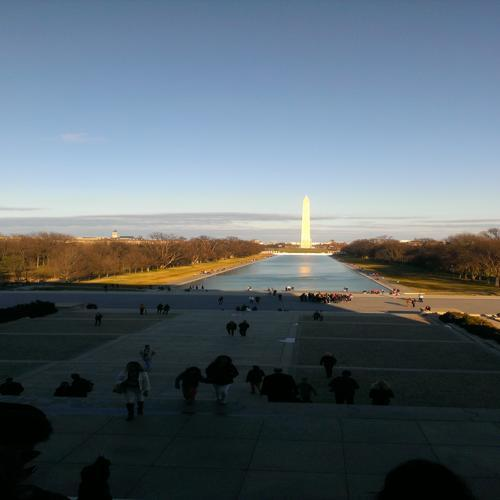How do people usually engage with this area in the image? People engage with this area in various ways. It's a popular spot for tourists to visit and take photographs. The expansive open areas are also a frequent choice for picnickers, joggers, and those seeking a quiet place for contemplation. Additionally, due to its historical significance, it often serves as a gathering place for civic events and celebrations. What time of the day does this image seem to capture, and why is that significant? The image appears to capture the time during late afternoon or early evening, as indicated by the long shadows and the warm, soft lighting. This time of day often brings a tranquil atmosphere to the area, allowing individuals to enjoy the monument and its surroundings in a less crowded and more reflective state, which can enhance the experience of its historical and cultural significance. 